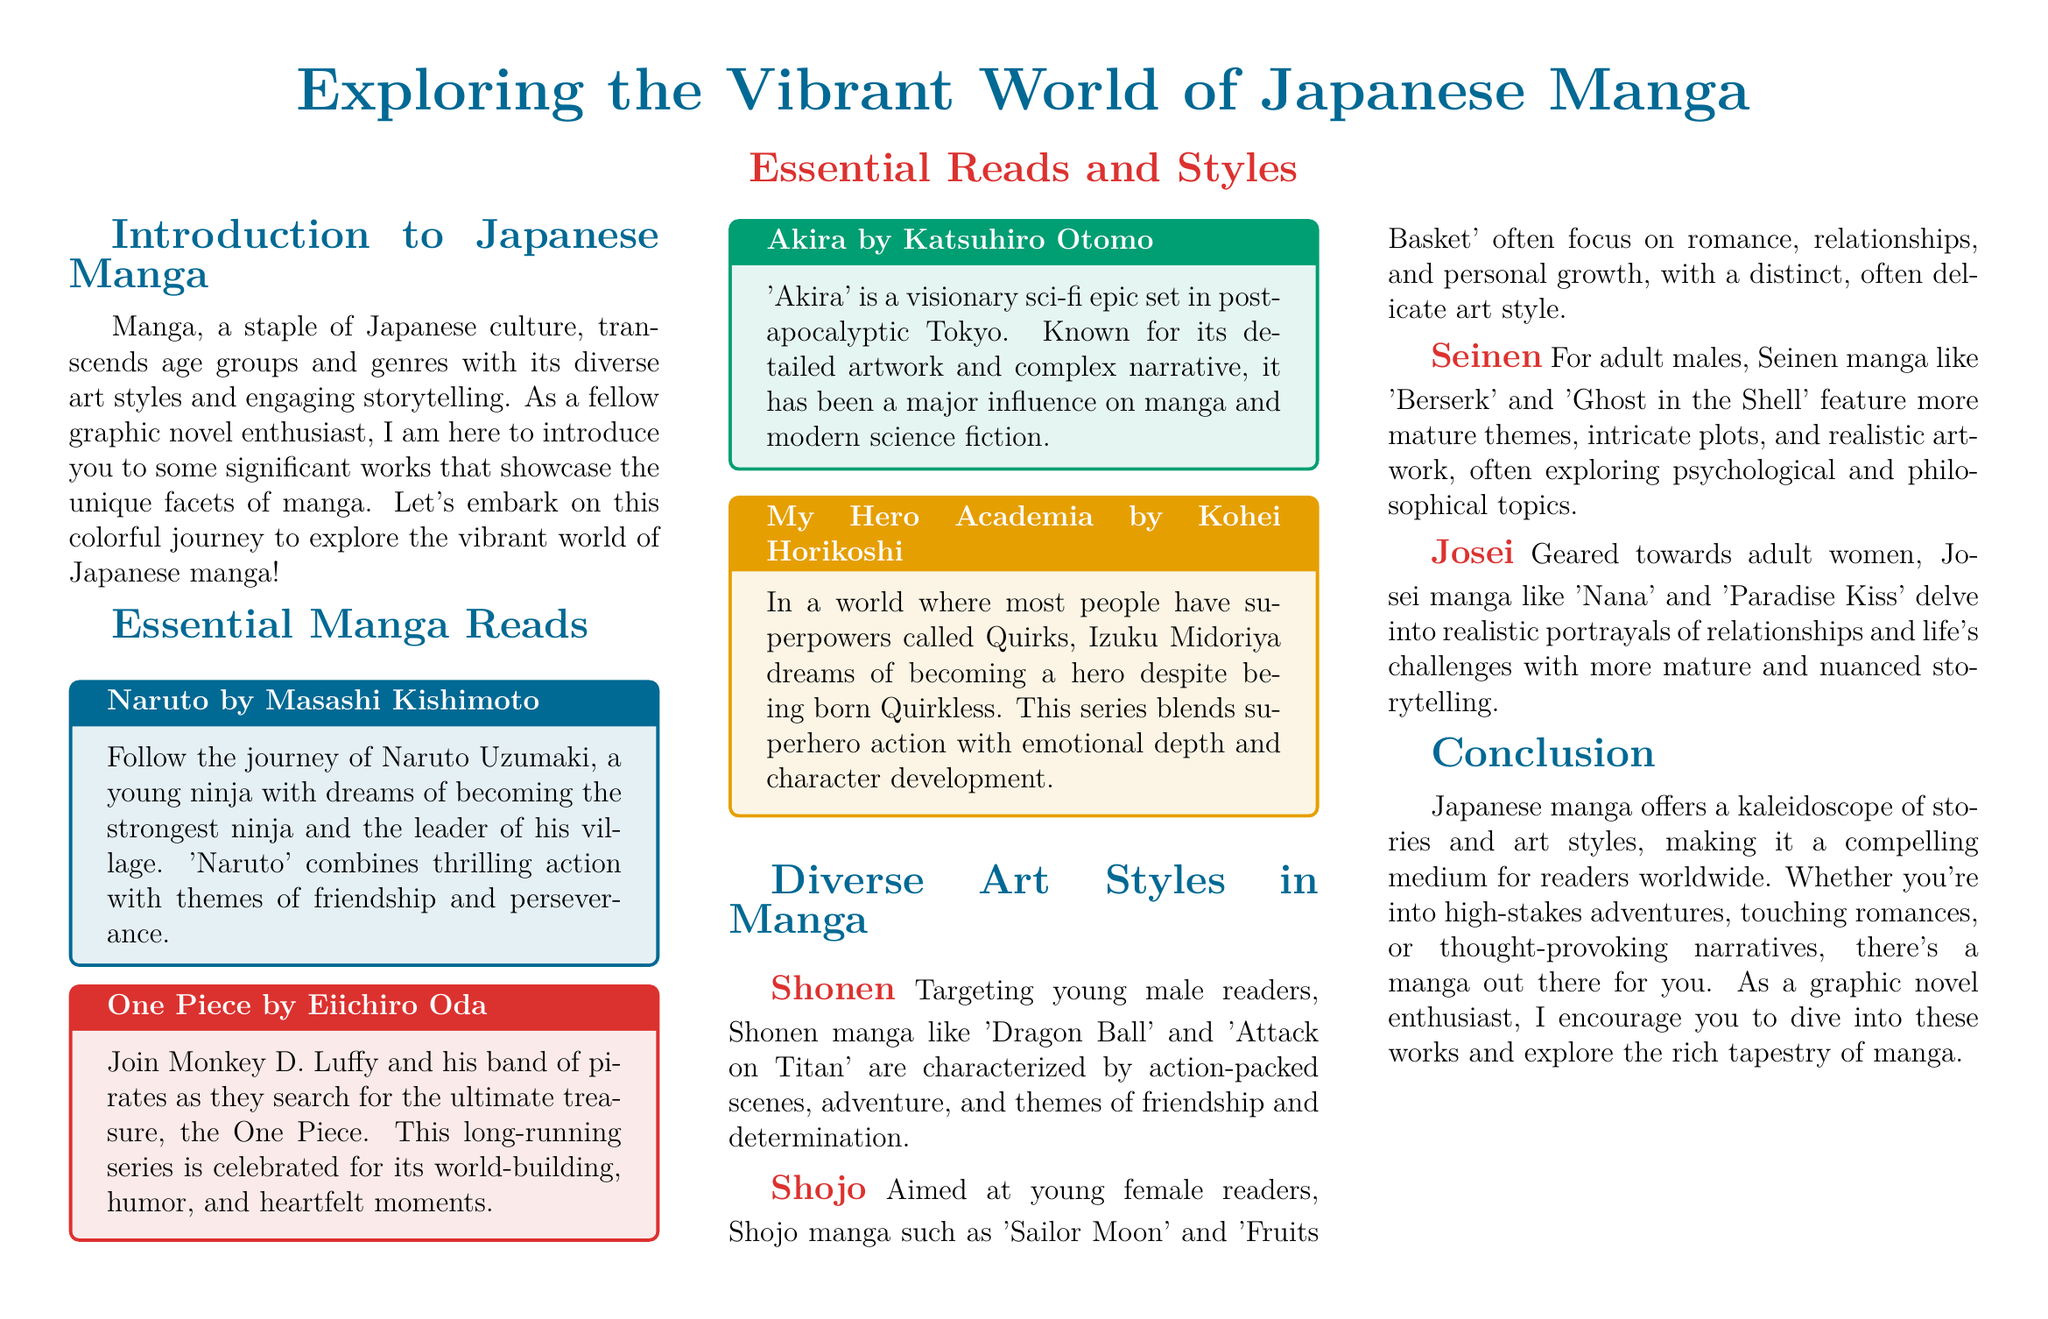What is the main theme of Naruto? Naruto follows the journey of a young ninja with dreams of becoming the strongest ninja and the leader of his village, combining action with themes of friendship and perseverance.
Answer: Friendship and perseverance Who is the author of One Piece? The document states that One Piece is written by Eiichiro Oda.
Answer: Eiichiro Oda What genre does Akira belong to? Akira is classified as a visionary sci-fi epic set in post-apocalyptic Tokyo.
Answer: Sci-fi Which manga targets young female readers? The document lists Shojo manga aimed at young female readers such as Sailor Moon and Fruits Basket.
Answer: Shojo What does the term Seinen refer to in manga? Seinen targets adult males and features mature themes, intricate plots, and realistic artwork.
Answer: Adult males How many essential manga reads are listed in the document? The document includes a total of four essential manga reads: Naruto, One Piece, Akira, and My Hero Academia.
Answer: Four What is the art style focus of Shojo manga? Shojo manga often focuses on romance, relationships, and personal growth with a delicate art style.
Answer: Delicate art style Which manga combines superhero action with emotional depth? My Hero Academia is noted for blending superhero action with emotional depth and character development.
Answer: My Hero Academia What is the conclusion of the introduction section? The conclusion emphasizes that Japanese manga offers diverse stories and art styles compelling for readers worldwide.
Answer: Diverse stories and art styles 